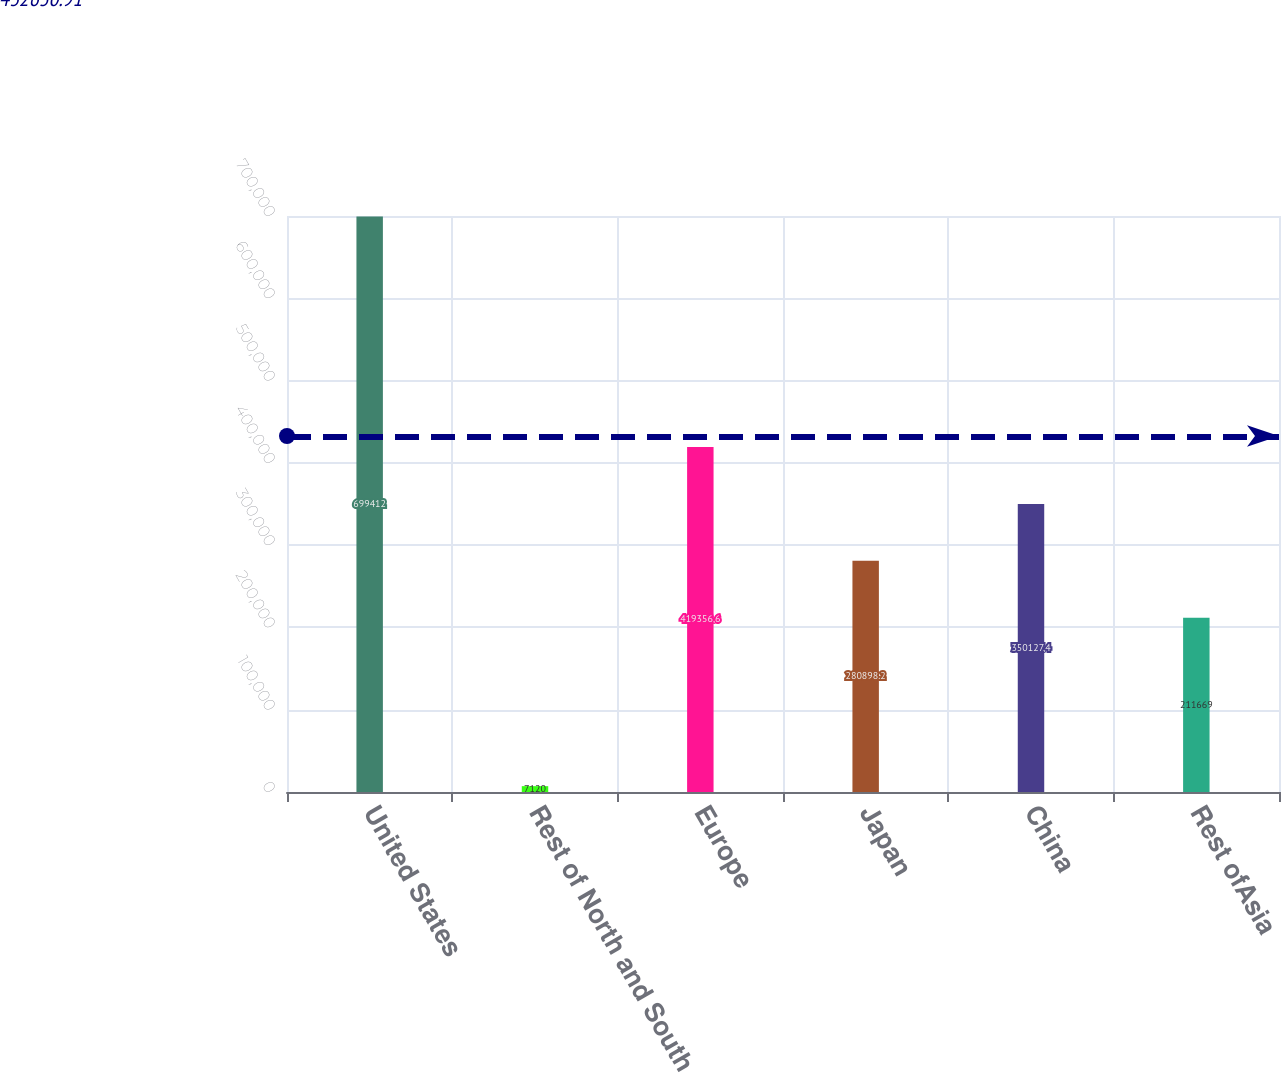Convert chart to OTSL. <chart><loc_0><loc_0><loc_500><loc_500><bar_chart><fcel>United States<fcel>Rest of North and South<fcel>Europe<fcel>Japan<fcel>China<fcel>Rest ofAsia<nl><fcel>699412<fcel>7120<fcel>419357<fcel>280898<fcel>350127<fcel>211669<nl></chart> 